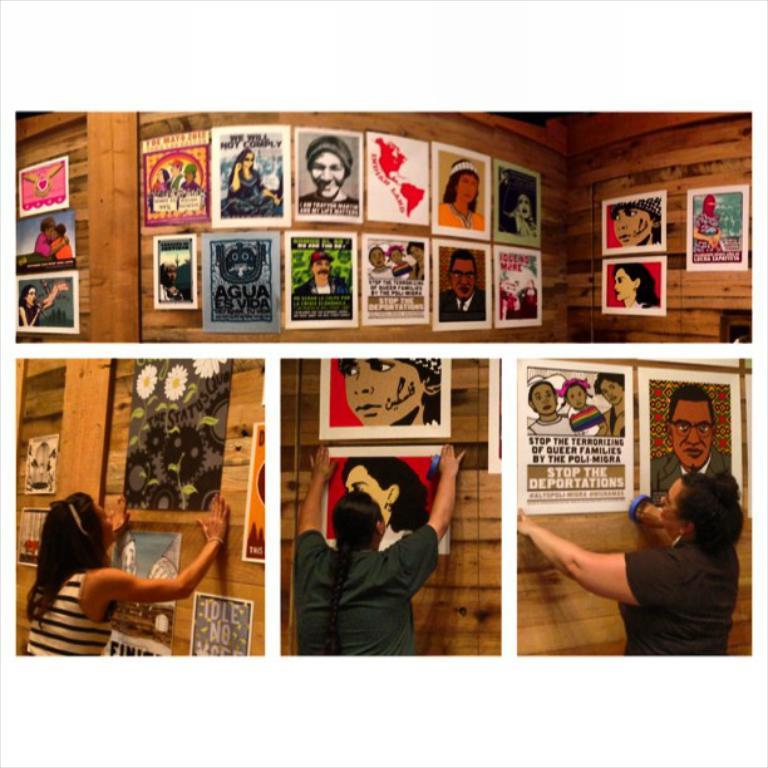What is the composition of the image? The image is a collage of four pictures. What can be seen in the pictures? In at least one of the pictures, there are posters on the wall. What are the people doing in some of the pictures? In some of the pictures, people are posting images on the wall. What type of breakfast is being served in the image? There is no breakfast present in the image; it is a collage of pictures with posters and people posting images on the wall. Can you tell me what time it is in the image based on the watch? There is no watch present in the image. 